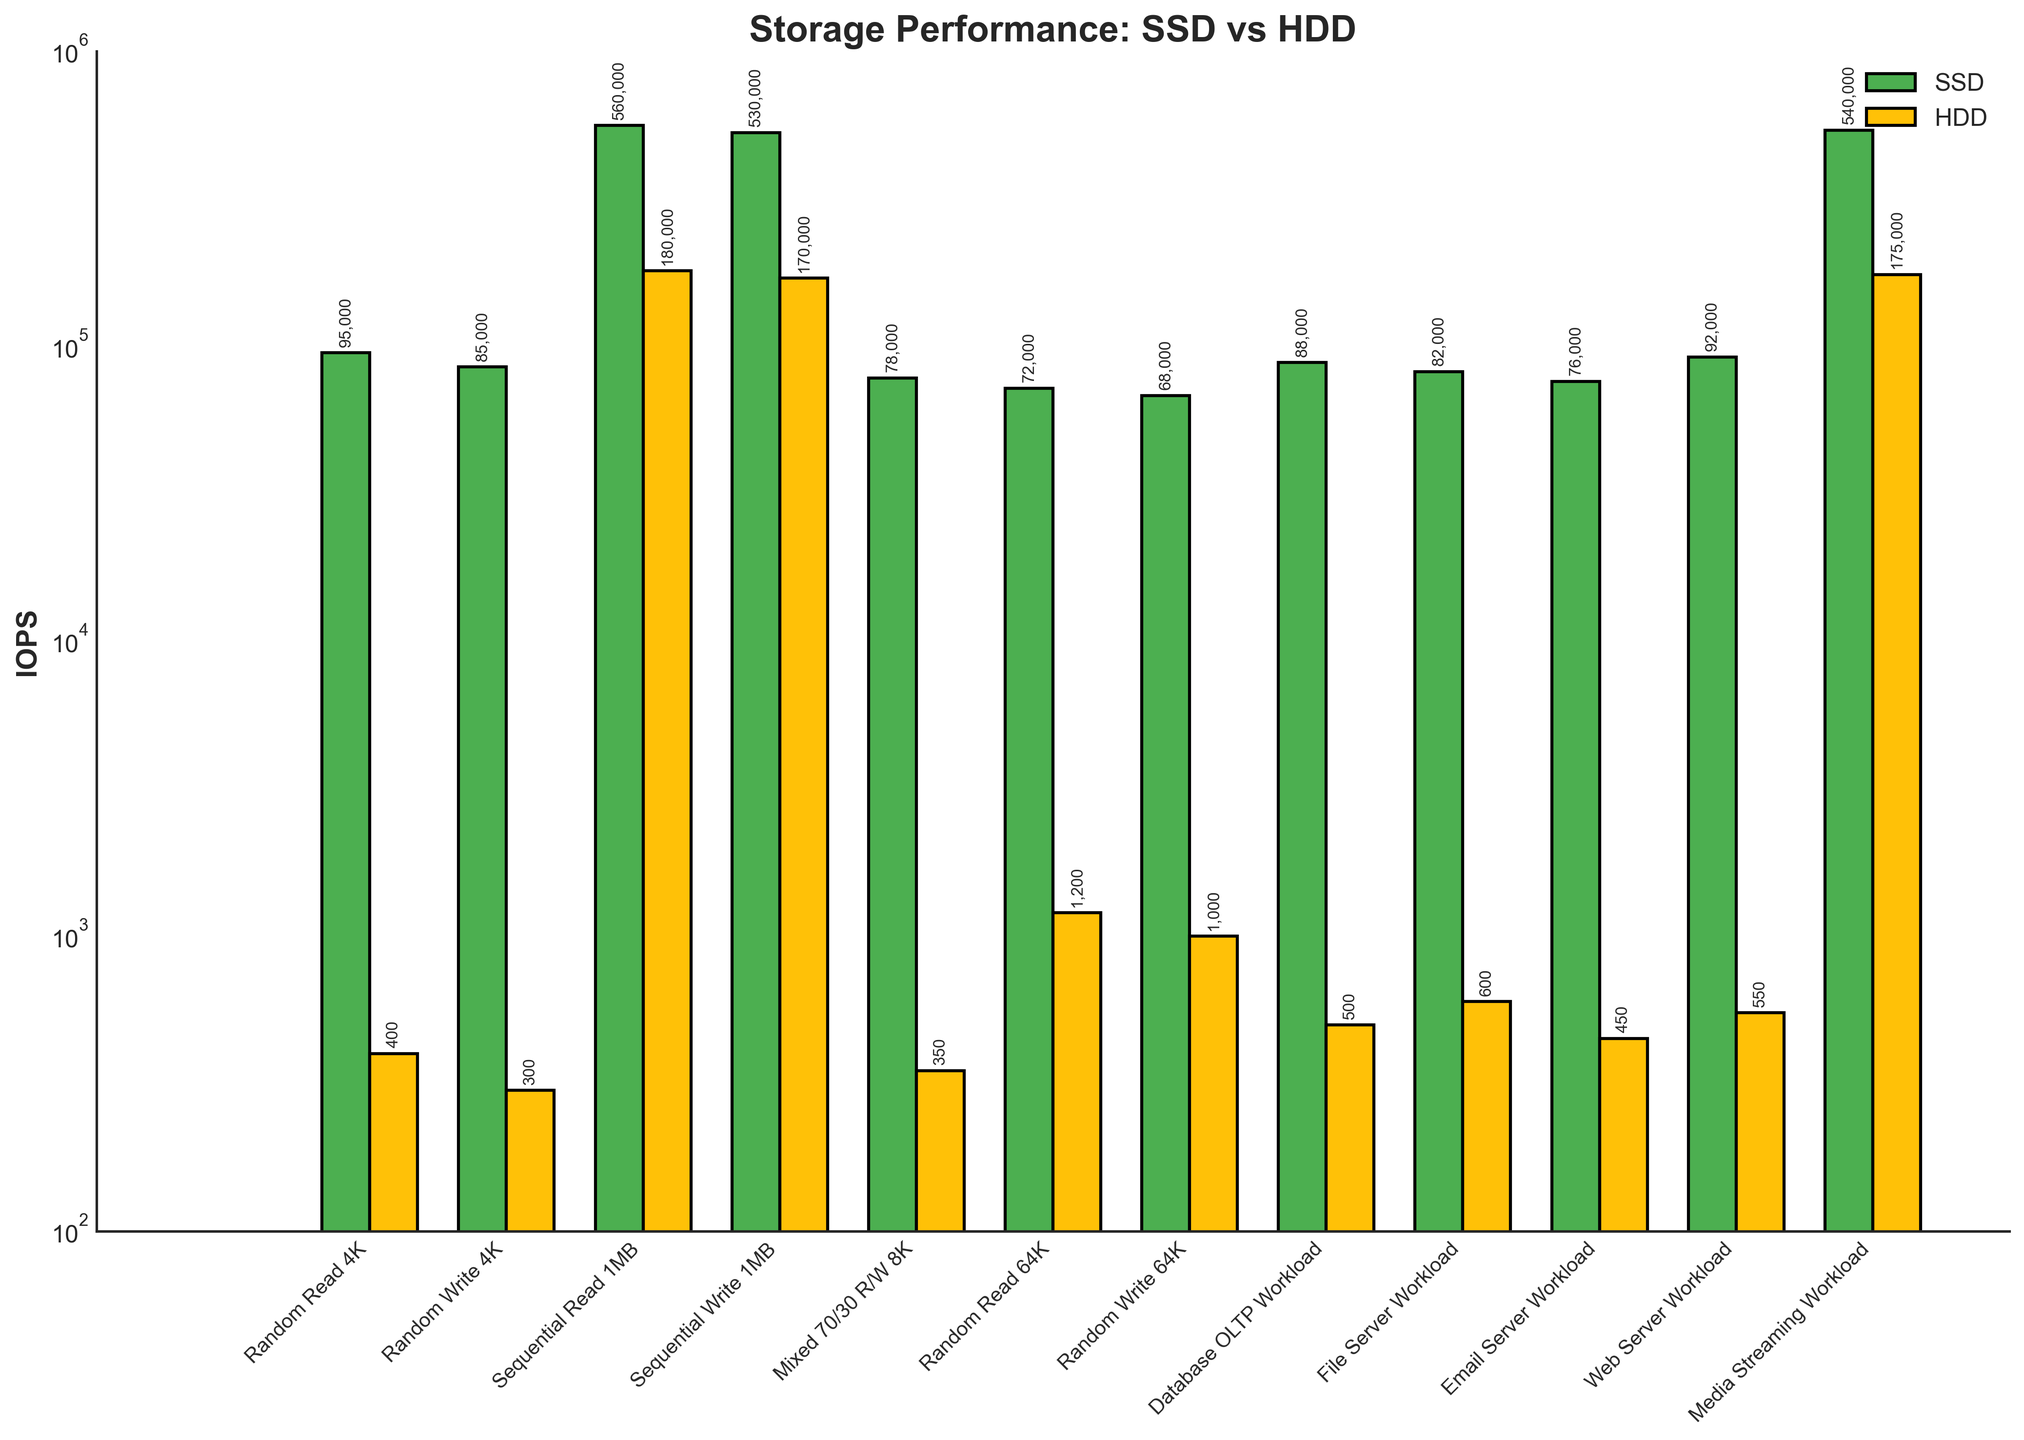Which operation shows the greatest performance difference between SSD and HDD? Calculate the performance difference for each operation, and identify the highest value. For Sequential Read 1MB, the difference is 560,000 - 180,000 = 380,000 IOPS, which is the greatest among all operations.
Answer: Sequential Read 1MB What is the average IOPS for SSD across all operations? Sum the IOPS values for SSD across all operations and divide by the number of operations. The sum is 1,317,000, and there are 12 operations, so the average is 1,317,000 / 12 = 109,750 IOPS.
Answer: 109,750 IOPS What is the ratio of SSD to HDD IOPS for the File Server Workload? Look at the File Server Workload and divide SSD IOPS by HDD IOPS. For File Server Workload, the ratio is 82,000 / 600 ≈ 136.67.
Answer: 136.67 For which operation do HDDs outperform SSDs? Visually inspect the bars. None of the operations show HDDs outperforming SSDs.
Answer: None What is the median IOPS for HDDs in all operations? Arrange the HDD IOPS values in ascending order and find the middle number. The values are 300, 350, 400, 450, 500, 550, 600, 1000, 1200, 170000, 175000, 180000. The median IOPS is (550+600)/2 = 575.
Answer: 575 IOPS Which workload has the smallest difference in IOPS between SSD and HDD? Calculate the differences for each workload and identify the smallest one. For File Server Workload, the difference is 82,000 - 600 = 81,400 IOPS, which is the smallest difference among all workloads.
Answer: File Server Workload How many SSD operations have IOPS greater than 100,000? Count the number of SSD IOPS values greater than 100,000. There are three such operations: Sequential Read 1MB (560,000), Sequential Write 1MB (530,000), Media Streaming Workload (540,000).
Answer: 3 operations 